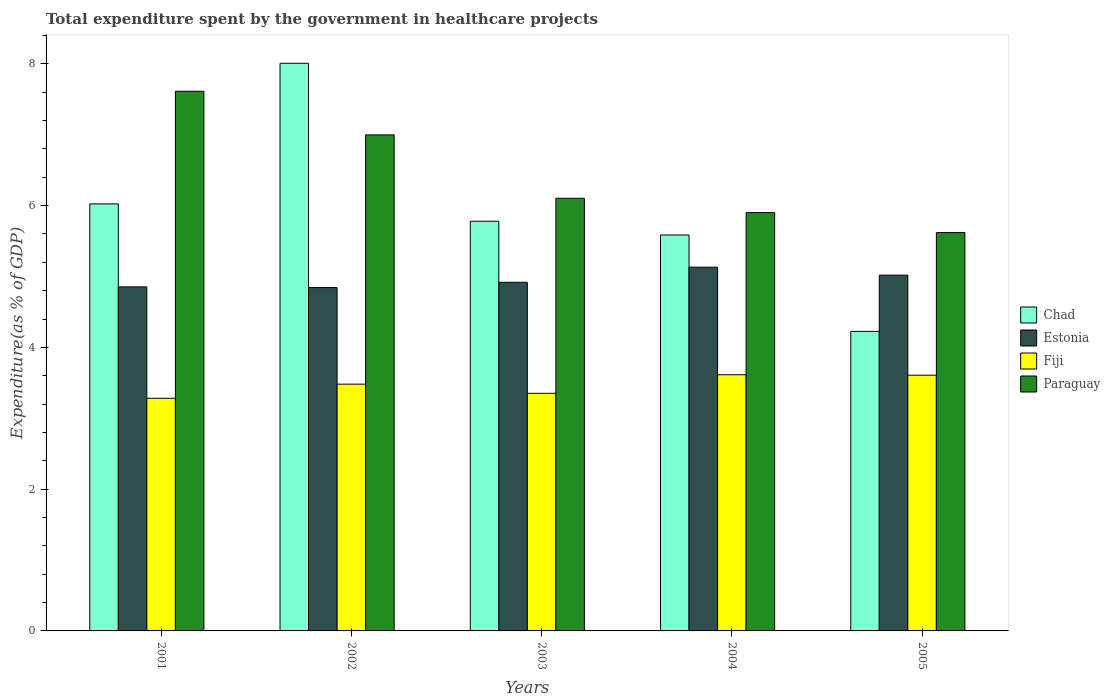How many groups of bars are there?
Keep it short and to the point. 5. Are the number of bars per tick equal to the number of legend labels?
Provide a succinct answer. Yes. What is the label of the 2nd group of bars from the left?
Offer a very short reply. 2002. In how many cases, is the number of bars for a given year not equal to the number of legend labels?
Make the answer very short. 0. What is the total expenditure spent by the government in healthcare projects in Chad in 2002?
Keep it short and to the point. 8.01. Across all years, what is the maximum total expenditure spent by the government in healthcare projects in Fiji?
Offer a terse response. 3.61. Across all years, what is the minimum total expenditure spent by the government in healthcare projects in Chad?
Your answer should be compact. 4.23. In which year was the total expenditure spent by the government in healthcare projects in Paraguay maximum?
Offer a terse response. 2001. What is the total total expenditure spent by the government in healthcare projects in Paraguay in the graph?
Make the answer very short. 32.24. What is the difference between the total expenditure spent by the government in healthcare projects in Chad in 2002 and that in 2004?
Provide a succinct answer. 2.42. What is the difference between the total expenditure spent by the government in healthcare projects in Paraguay in 2003 and the total expenditure spent by the government in healthcare projects in Estonia in 2002?
Ensure brevity in your answer.  1.26. What is the average total expenditure spent by the government in healthcare projects in Chad per year?
Your response must be concise. 5.93. In the year 2002, what is the difference between the total expenditure spent by the government in healthcare projects in Paraguay and total expenditure spent by the government in healthcare projects in Fiji?
Offer a terse response. 3.52. In how many years, is the total expenditure spent by the government in healthcare projects in Fiji greater than 0.4 %?
Your response must be concise. 5. What is the ratio of the total expenditure spent by the government in healthcare projects in Paraguay in 2001 to that in 2004?
Give a very brief answer. 1.29. What is the difference between the highest and the second highest total expenditure spent by the government in healthcare projects in Chad?
Offer a terse response. 1.98. What is the difference between the highest and the lowest total expenditure spent by the government in healthcare projects in Chad?
Provide a short and direct response. 3.78. Is it the case that in every year, the sum of the total expenditure spent by the government in healthcare projects in Estonia and total expenditure spent by the government in healthcare projects in Chad is greater than the sum of total expenditure spent by the government in healthcare projects in Fiji and total expenditure spent by the government in healthcare projects in Paraguay?
Your answer should be compact. Yes. What does the 4th bar from the left in 2004 represents?
Your response must be concise. Paraguay. What does the 4th bar from the right in 2003 represents?
Make the answer very short. Chad. Are all the bars in the graph horizontal?
Offer a very short reply. No. Does the graph contain any zero values?
Offer a terse response. No. Does the graph contain grids?
Offer a terse response. No. How many legend labels are there?
Your answer should be compact. 4. How are the legend labels stacked?
Your answer should be compact. Vertical. What is the title of the graph?
Offer a terse response. Total expenditure spent by the government in healthcare projects. Does "Madagascar" appear as one of the legend labels in the graph?
Offer a terse response. No. What is the label or title of the X-axis?
Provide a succinct answer. Years. What is the label or title of the Y-axis?
Ensure brevity in your answer.  Expenditure(as % of GDP). What is the Expenditure(as % of GDP) in Chad in 2001?
Your answer should be compact. 6.02. What is the Expenditure(as % of GDP) in Estonia in 2001?
Provide a short and direct response. 4.85. What is the Expenditure(as % of GDP) in Fiji in 2001?
Keep it short and to the point. 3.28. What is the Expenditure(as % of GDP) in Paraguay in 2001?
Offer a terse response. 7.61. What is the Expenditure(as % of GDP) of Chad in 2002?
Offer a very short reply. 8.01. What is the Expenditure(as % of GDP) in Estonia in 2002?
Offer a very short reply. 4.84. What is the Expenditure(as % of GDP) of Fiji in 2002?
Make the answer very short. 3.48. What is the Expenditure(as % of GDP) of Paraguay in 2002?
Your response must be concise. 7. What is the Expenditure(as % of GDP) of Chad in 2003?
Give a very brief answer. 5.78. What is the Expenditure(as % of GDP) of Estonia in 2003?
Offer a terse response. 4.92. What is the Expenditure(as % of GDP) of Fiji in 2003?
Offer a very short reply. 3.35. What is the Expenditure(as % of GDP) in Paraguay in 2003?
Give a very brief answer. 6.1. What is the Expenditure(as % of GDP) of Chad in 2004?
Make the answer very short. 5.59. What is the Expenditure(as % of GDP) of Estonia in 2004?
Your answer should be very brief. 5.13. What is the Expenditure(as % of GDP) of Fiji in 2004?
Offer a terse response. 3.61. What is the Expenditure(as % of GDP) of Paraguay in 2004?
Your answer should be compact. 5.9. What is the Expenditure(as % of GDP) of Chad in 2005?
Offer a very short reply. 4.23. What is the Expenditure(as % of GDP) in Estonia in 2005?
Make the answer very short. 5.02. What is the Expenditure(as % of GDP) of Fiji in 2005?
Your response must be concise. 3.61. What is the Expenditure(as % of GDP) in Paraguay in 2005?
Offer a very short reply. 5.62. Across all years, what is the maximum Expenditure(as % of GDP) in Chad?
Your answer should be compact. 8.01. Across all years, what is the maximum Expenditure(as % of GDP) of Estonia?
Your answer should be compact. 5.13. Across all years, what is the maximum Expenditure(as % of GDP) of Fiji?
Ensure brevity in your answer.  3.61. Across all years, what is the maximum Expenditure(as % of GDP) in Paraguay?
Your response must be concise. 7.61. Across all years, what is the minimum Expenditure(as % of GDP) of Chad?
Provide a succinct answer. 4.23. Across all years, what is the minimum Expenditure(as % of GDP) of Estonia?
Your response must be concise. 4.84. Across all years, what is the minimum Expenditure(as % of GDP) of Fiji?
Make the answer very short. 3.28. Across all years, what is the minimum Expenditure(as % of GDP) of Paraguay?
Your answer should be compact. 5.62. What is the total Expenditure(as % of GDP) in Chad in the graph?
Give a very brief answer. 29.63. What is the total Expenditure(as % of GDP) in Estonia in the graph?
Your answer should be compact. 24.77. What is the total Expenditure(as % of GDP) of Fiji in the graph?
Offer a terse response. 17.34. What is the total Expenditure(as % of GDP) of Paraguay in the graph?
Give a very brief answer. 32.24. What is the difference between the Expenditure(as % of GDP) in Chad in 2001 and that in 2002?
Your answer should be compact. -1.98. What is the difference between the Expenditure(as % of GDP) of Estonia in 2001 and that in 2002?
Ensure brevity in your answer.  0.01. What is the difference between the Expenditure(as % of GDP) in Fiji in 2001 and that in 2002?
Offer a terse response. -0.2. What is the difference between the Expenditure(as % of GDP) in Paraguay in 2001 and that in 2002?
Your answer should be very brief. 0.62. What is the difference between the Expenditure(as % of GDP) of Chad in 2001 and that in 2003?
Provide a short and direct response. 0.24. What is the difference between the Expenditure(as % of GDP) in Estonia in 2001 and that in 2003?
Give a very brief answer. -0.06. What is the difference between the Expenditure(as % of GDP) of Fiji in 2001 and that in 2003?
Your answer should be very brief. -0.07. What is the difference between the Expenditure(as % of GDP) of Paraguay in 2001 and that in 2003?
Your answer should be compact. 1.51. What is the difference between the Expenditure(as % of GDP) in Chad in 2001 and that in 2004?
Offer a terse response. 0.44. What is the difference between the Expenditure(as % of GDP) in Estonia in 2001 and that in 2004?
Give a very brief answer. -0.28. What is the difference between the Expenditure(as % of GDP) of Fiji in 2001 and that in 2004?
Your answer should be compact. -0.33. What is the difference between the Expenditure(as % of GDP) in Paraguay in 2001 and that in 2004?
Provide a short and direct response. 1.71. What is the difference between the Expenditure(as % of GDP) of Chad in 2001 and that in 2005?
Provide a short and direct response. 1.8. What is the difference between the Expenditure(as % of GDP) of Estonia in 2001 and that in 2005?
Your answer should be compact. -0.17. What is the difference between the Expenditure(as % of GDP) of Fiji in 2001 and that in 2005?
Your response must be concise. -0.33. What is the difference between the Expenditure(as % of GDP) of Paraguay in 2001 and that in 2005?
Your response must be concise. 1.99. What is the difference between the Expenditure(as % of GDP) of Chad in 2002 and that in 2003?
Give a very brief answer. 2.23. What is the difference between the Expenditure(as % of GDP) of Estonia in 2002 and that in 2003?
Keep it short and to the point. -0.07. What is the difference between the Expenditure(as % of GDP) in Fiji in 2002 and that in 2003?
Keep it short and to the point. 0.13. What is the difference between the Expenditure(as % of GDP) in Paraguay in 2002 and that in 2003?
Your response must be concise. 0.89. What is the difference between the Expenditure(as % of GDP) in Chad in 2002 and that in 2004?
Ensure brevity in your answer.  2.42. What is the difference between the Expenditure(as % of GDP) in Estonia in 2002 and that in 2004?
Give a very brief answer. -0.29. What is the difference between the Expenditure(as % of GDP) in Fiji in 2002 and that in 2004?
Offer a very short reply. -0.13. What is the difference between the Expenditure(as % of GDP) of Paraguay in 2002 and that in 2004?
Give a very brief answer. 1.1. What is the difference between the Expenditure(as % of GDP) in Chad in 2002 and that in 2005?
Ensure brevity in your answer.  3.78. What is the difference between the Expenditure(as % of GDP) in Estonia in 2002 and that in 2005?
Make the answer very short. -0.18. What is the difference between the Expenditure(as % of GDP) of Fiji in 2002 and that in 2005?
Your answer should be very brief. -0.13. What is the difference between the Expenditure(as % of GDP) of Paraguay in 2002 and that in 2005?
Make the answer very short. 1.38. What is the difference between the Expenditure(as % of GDP) of Chad in 2003 and that in 2004?
Provide a succinct answer. 0.19. What is the difference between the Expenditure(as % of GDP) of Estonia in 2003 and that in 2004?
Your answer should be very brief. -0.21. What is the difference between the Expenditure(as % of GDP) of Fiji in 2003 and that in 2004?
Provide a short and direct response. -0.26. What is the difference between the Expenditure(as % of GDP) in Paraguay in 2003 and that in 2004?
Your answer should be very brief. 0.2. What is the difference between the Expenditure(as % of GDP) in Chad in 2003 and that in 2005?
Offer a terse response. 1.55. What is the difference between the Expenditure(as % of GDP) of Estonia in 2003 and that in 2005?
Ensure brevity in your answer.  -0.1. What is the difference between the Expenditure(as % of GDP) in Fiji in 2003 and that in 2005?
Give a very brief answer. -0.26. What is the difference between the Expenditure(as % of GDP) of Paraguay in 2003 and that in 2005?
Keep it short and to the point. 0.48. What is the difference between the Expenditure(as % of GDP) of Chad in 2004 and that in 2005?
Make the answer very short. 1.36. What is the difference between the Expenditure(as % of GDP) of Estonia in 2004 and that in 2005?
Your response must be concise. 0.11. What is the difference between the Expenditure(as % of GDP) of Fiji in 2004 and that in 2005?
Make the answer very short. 0.01. What is the difference between the Expenditure(as % of GDP) of Paraguay in 2004 and that in 2005?
Your answer should be compact. 0.28. What is the difference between the Expenditure(as % of GDP) of Chad in 2001 and the Expenditure(as % of GDP) of Estonia in 2002?
Give a very brief answer. 1.18. What is the difference between the Expenditure(as % of GDP) of Chad in 2001 and the Expenditure(as % of GDP) of Fiji in 2002?
Offer a terse response. 2.54. What is the difference between the Expenditure(as % of GDP) in Chad in 2001 and the Expenditure(as % of GDP) in Paraguay in 2002?
Give a very brief answer. -0.97. What is the difference between the Expenditure(as % of GDP) of Estonia in 2001 and the Expenditure(as % of GDP) of Fiji in 2002?
Provide a succinct answer. 1.37. What is the difference between the Expenditure(as % of GDP) in Estonia in 2001 and the Expenditure(as % of GDP) in Paraguay in 2002?
Your response must be concise. -2.14. What is the difference between the Expenditure(as % of GDP) in Fiji in 2001 and the Expenditure(as % of GDP) in Paraguay in 2002?
Provide a succinct answer. -3.72. What is the difference between the Expenditure(as % of GDP) in Chad in 2001 and the Expenditure(as % of GDP) in Estonia in 2003?
Offer a terse response. 1.11. What is the difference between the Expenditure(as % of GDP) in Chad in 2001 and the Expenditure(as % of GDP) in Fiji in 2003?
Your answer should be compact. 2.67. What is the difference between the Expenditure(as % of GDP) of Chad in 2001 and the Expenditure(as % of GDP) of Paraguay in 2003?
Make the answer very short. -0.08. What is the difference between the Expenditure(as % of GDP) of Estonia in 2001 and the Expenditure(as % of GDP) of Fiji in 2003?
Give a very brief answer. 1.5. What is the difference between the Expenditure(as % of GDP) of Estonia in 2001 and the Expenditure(as % of GDP) of Paraguay in 2003?
Provide a short and direct response. -1.25. What is the difference between the Expenditure(as % of GDP) of Fiji in 2001 and the Expenditure(as % of GDP) of Paraguay in 2003?
Offer a terse response. -2.82. What is the difference between the Expenditure(as % of GDP) in Chad in 2001 and the Expenditure(as % of GDP) in Estonia in 2004?
Ensure brevity in your answer.  0.89. What is the difference between the Expenditure(as % of GDP) in Chad in 2001 and the Expenditure(as % of GDP) in Fiji in 2004?
Your answer should be compact. 2.41. What is the difference between the Expenditure(as % of GDP) in Chad in 2001 and the Expenditure(as % of GDP) in Paraguay in 2004?
Your answer should be compact. 0.12. What is the difference between the Expenditure(as % of GDP) of Estonia in 2001 and the Expenditure(as % of GDP) of Fiji in 2004?
Ensure brevity in your answer.  1.24. What is the difference between the Expenditure(as % of GDP) in Estonia in 2001 and the Expenditure(as % of GDP) in Paraguay in 2004?
Offer a very short reply. -1.05. What is the difference between the Expenditure(as % of GDP) in Fiji in 2001 and the Expenditure(as % of GDP) in Paraguay in 2004?
Your response must be concise. -2.62. What is the difference between the Expenditure(as % of GDP) in Chad in 2001 and the Expenditure(as % of GDP) in Estonia in 2005?
Offer a terse response. 1. What is the difference between the Expenditure(as % of GDP) of Chad in 2001 and the Expenditure(as % of GDP) of Fiji in 2005?
Provide a succinct answer. 2.42. What is the difference between the Expenditure(as % of GDP) of Chad in 2001 and the Expenditure(as % of GDP) of Paraguay in 2005?
Offer a very short reply. 0.4. What is the difference between the Expenditure(as % of GDP) in Estonia in 2001 and the Expenditure(as % of GDP) in Fiji in 2005?
Your response must be concise. 1.25. What is the difference between the Expenditure(as % of GDP) of Estonia in 2001 and the Expenditure(as % of GDP) of Paraguay in 2005?
Provide a short and direct response. -0.77. What is the difference between the Expenditure(as % of GDP) of Fiji in 2001 and the Expenditure(as % of GDP) of Paraguay in 2005?
Provide a short and direct response. -2.34. What is the difference between the Expenditure(as % of GDP) of Chad in 2002 and the Expenditure(as % of GDP) of Estonia in 2003?
Your answer should be compact. 3.09. What is the difference between the Expenditure(as % of GDP) of Chad in 2002 and the Expenditure(as % of GDP) of Fiji in 2003?
Provide a short and direct response. 4.66. What is the difference between the Expenditure(as % of GDP) in Chad in 2002 and the Expenditure(as % of GDP) in Paraguay in 2003?
Your answer should be very brief. 1.9. What is the difference between the Expenditure(as % of GDP) in Estonia in 2002 and the Expenditure(as % of GDP) in Fiji in 2003?
Provide a short and direct response. 1.49. What is the difference between the Expenditure(as % of GDP) in Estonia in 2002 and the Expenditure(as % of GDP) in Paraguay in 2003?
Give a very brief answer. -1.26. What is the difference between the Expenditure(as % of GDP) of Fiji in 2002 and the Expenditure(as % of GDP) of Paraguay in 2003?
Offer a terse response. -2.62. What is the difference between the Expenditure(as % of GDP) in Chad in 2002 and the Expenditure(as % of GDP) in Estonia in 2004?
Your response must be concise. 2.88. What is the difference between the Expenditure(as % of GDP) of Chad in 2002 and the Expenditure(as % of GDP) of Fiji in 2004?
Make the answer very short. 4.39. What is the difference between the Expenditure(as % of GDP) in Chad in 2002 and the Expenditure(as % of GDP) in Paraguay in 2004?
Provide a short and direct response. 2.11. What is the difference between the Expenditure(as % of GDP) of Estonia in 2002 and the Expenditure(as % of GDP) of Fiji in 2004?
Keep it short and to the point. 1.23. What is the difference between the Expenditure(as % of GDP) in Estonia in 2002 and the Expenditure(as % of GDP) in Paraguay in 2004?
Your answer should be compact. -1.06. What is the difference between the Expenditure(as % of GDP) of Fiji in 2002 and the Expenditure(as % of GDP) of Paraguay in 2004?
Your response must be concise. -2.42. What is the difference between the Expenditure(as % of GDP) in Chad in 2002 and the Expenditure(as % of GDP) in Estonia in 2005?
Make the answer very short. 2.99. What is the difference between the Expenditure(as % of GDP) of Chad in 2002 and the Expenditure(as % of GDP) of Fiji in 2005?
Ensure brevity in your answer.  4.4. What is the difference between the Expenditure(as % of GDP) in Chad in 2002 and the Expenditure(as % of GDP) in Paraguay in 2005?
Your answer should be compact. 2.39. What is the difference between the Expenditure(as % of GDP) in Estonia in 2002 and the Expenditure(as % of GDP) in Fiji in 2005?
Make the answer very short. 1.24. What is the difference between the Expenditure(as % of GDP) of Estonia in 2002 and the Expenditure(as % of GDP) of Paraguay in 2005?
Ensure brevity in your answer.  -0.78. What is the difference between the Expenditure(as % of GDP) of Fiji in 2002 and the Expenditure(as % of GDP) of Paraguay in 2005?
Your response must be concise. -2.14. What is the difference between the Expenditure(as % of GDP) in Chad in 2003 and the Expenditure(as % of GDP) in Estonia in 2004?
Offer a very short reply. 0.65. What is the difference between the Expenditure(as % of GDP) of Chad in 2003 and the Expenditure(as % of GDP) of Fiji in 2004?
Give a very brief answer. 2.17. What is the difference between the Expenditure(as % of GDP) of Chad in 2003 and the Expenditure(as % of GDP) of Paraguay in 2004?
Give a very brief answer. -0.12. What is the difference between the Expenditure(as % of GDP) in Estonia in 2003 and the Expenditure(as % of GDP) in Fiji in 2004?
Provide a succinct answer. 1.3. What is the difference between the Expenditure(as % of GDP) in Estonia in 2003 and the Expenditure(as % of GDP) in Paraguay in 2004?
Ensure brevity in your answer.  -0.98. What is the difference between the Expenditure(as % of GDP) in Fiji in 2003 and the Expenditure(as % of GDP) in Paraguay in 2004?
Make the answer very short. -2.55. What is the difference between the Expenditure(as % of GDP) of Chad in 2003 and the Expenditure(as % of GDP) of Estonia in 2005?
Your response must be concise. 0.76. What is the difference between the Expenditure(as % of GDP) of Chad in 2003 and the Expenditure(as % of GDP) of Fiji in 2005?
Make the answer very short. 2.17. What is the difference between the Expenditure(as % of GDP) in Chad in 2003 and the Expenditure(as % of GDP) in Paraguay in 2005?
Offer a very short reply. 0.16. What is the difference between the Expenditure(as % of GDP) in Estonia in 2003 and the Expenditure(as % of GDP) in Fiji in 2005?
Ensure brevity in your answer.  1.31. What is the difference between the Expenditure(as % of GDP) of Estonia in 2003 and the Expenditure(as % of GDP) of Paraguay in 2005?
Provide a succinct answer. -0.7. What is the difference between the Expenditure(as % of GDP) in Fiji in 2003 and the Expenditure(as % of GDP) in Paraguay in 2005?
Ensure brevity in your answer.  -2.27. What is the difference between the Expenditure(as % of GDP) in Chad in 2004 and the Expenditure(as % of GDP) in Estonia in 2005?
Your answer should be very brief. 0.57. What is the difference between the Expenditure(as % of GDP) of Chad in 2004 and the Expenditure(as % of GDP) of Fiji in 2005?
Your response must be concise. 1.98. What is the difference between the Expenditure(as % of GDP) of Chad in 2004 and the Expenditure(as % of GDP) of Paraguay in 2005?
Your answer should be compact. -0.03. What is the difference between the Expenditure(as % of GDP) in Estonia in 2004 and the Expenditure(as % of GDP) in Fiji in 2005?
Your answer should be compact. 1.52. What is the difference between the Expenditure(as % of GDP) in Estonia in 2004 and the Expenditure(as % of GDP) in Paraguay in 2005?
Keep it short and to the point. -0.49. What is the difference between the Expenditure(as % of GDP) of Fiji in 2004 and the Expenditure(as % of GDP) of Paraguay in 2005?
Give a very brief answer. -2.01. What is the average Expenditure(as % of GDP) of Chad per year?
Your response must be concise. 5.93. What is the average Expenditure(as % of GDP) of Estonia per year?
Your answer should be compact. 4.95. What is the average Expenditure(as % of GDP) in Fiji per year?
Ensure brevity in your answer.  3.47. What is the average Expenditure(as % of GDP) of Paraguay per year?
Your response must be concise. 6.45. In the year 2001, what is the difference between the Expenditure(as % of GDP) of Chad and Expenditure(as % of GDP) of Estonia?
Provide a succinct answer. 1.17. In the year 2001, what is the difference between the Expenditure(as % of GDP) in Chad and Expenditure(as % of GDP) in Fiji?
Keep it short and to the point. 2.74. In the year 2001, what is the difference between the Expenditure(as % of GDP) in Chad and Expenditure(as % of GDP) in Paraguay?
Keep it short and to the point. -1.59. In the year 2001, what is the difference between the Expenditure(as % of GDP) in Estonia and Expenditure(as % of GDP) in Fiji?
Ensure brevity in your answer.  1.57. In the year 2001, what is the difference between the Expenditure(as % of GDP) of Estonia and Expenditure(as % of GDP) of Paraguay?
Your answer should be compact. -2.76. In the year 2001, what is the difference between the Expenditure(as % of GDP) of Fiji and Expenditure(as % of GDP) of Paraguay?
Make the answer very short. -4.33. In the year 2002, what is the difference between the Expenditure(as % of GDP) of Chad and Expenditure(as % of GDP) of Estonia?
Give a very brief answer. 3.16. In the year 2002, what is the difference between the Expenditure(as % of GDP) of Chad and Expenditure(as % of GDP) of Fiji?
Keep it short and to the point. 4.53. In the year 2002, what is the difference between the Expenditure(as % of GDP) of Chad and Expenditure(as % of GDP) of Paraguay?
Ensure brevity in your answer.  1.01. In the year 2002, what is the difference between the Expenditure(as % of GDP) in Estonia and Expenditure(as % of GDP) in Fiji?
Offer a terse response. 1.36. In the year 2002, what is the difference between the Expenditure(as % of GDP) in Estonia and Expenditure(as % of GDP) in Paraguay?
Provide a short and direct response. -2.15. In the year 2002, what is the difference between the Expenditure(as % of GDP) of Fiji and Expenditure(as % of GDP) of Paraguay?
Offer a terse response. -3.52. In the year 2003, what is the difference between the Expenditure(as % of GDP) in Chad and Expenditure(as % of GDP) in Estonia?
Offer a very short reply. 0.86. In the year 2003, what is the difference between the Expenditure(as % of GDP) in Chad and Expenditure(as % of GDP) in Fiji?
Ensure brevity in your answer.  2.43. In the year 2003, what is the difference between the Expenditure(as % of GDP) of Chad and Expenditure(as % of GDP) of Paraguay?
Make the answer very short. -0.32. In the year 2003, what is the difference between the Expenditure(as % of GDP) of Estonia and Expenditure(as % of GDP) of Fiji?
Provide a short and direct response. 1.57. In the year 2003, what is the difference between the Expenditure(as % of GDP) of Estonia and Expenditure(as % of GDP) of Paraguay?
Give a very brief answer. -1.19. In the year 2003, what is the difference between the Expenditure(as % of GDP) in Fiji and Expenditure(as % of GDP) in Paraguay?
Your answer should be very brief. -2.75. In the year 2004, what is the difference between the Expenditure(as % of GDP) of Chad and Expenditure(as % of GDP) of Estonia?
Keep it short and to the point. 0.45. In the year 2004, what is the difference between the Expenditure(as % of GDP) of Chad and Expenditure(as % of GDP) of Fiji?
Ensure brevity in your answer.  1.97. In the year 2004, what is the difference between the Expenditure(as % of GDP) of Chad and Expenditure(as % of GDP) of Paraguay?
Provide a succinct answer. -0.32. In the year 2004, what is the difference between the Expenditure(as % of GDP) in Estonia and Expenditure(as % of GDP) in Fiji?
Keep it short and to the point. 1.52. In the year 2004, what is the difference between the Expenditure(as % of GDP) in Estonia and Expenditure(as % of GDP) in Paraguay?
Make the answer very short. -0.77. In the year 2004, what is the difference between the Expenditure(as % of GDP) of Fiji and Expenditure(as % of GDP) of Paraguay?
Your answer should be compact. -2.29. In the year 2005, what is the difference between the Expenditure(as % of GDP) in Chad and Expenditure(as % of GDP) in Estonia?
Ensure brevity in your answer.  -0.79. In the year 2005, what is the difference between the Expenditure(as % of GDP) of Chad and Expenditure(as % of GDP) of Fiji?
Your response must be concise. 0.62. In the year 2005, what is the difference between the Expenditure(as % of GDP) in Chad and Expenditure(as % of GDP) in Paraguay?
Your answer should be very brief. -1.39. In the year 2005, what is the difference between the Expenditure(as % of GDP) of Estonia and Expenditure(as % of GDP) of Fiji?
Your answer should be very brief. 1.41. In the year 2005, what is the difference between the Expenditure(as % of GDP) of Estonia and Expenditure(as % of GDP) of Paraguay?
Your answer should be very brief. -0.6. In the year 2005, what is the difference between the Expenditure(as % of GDP) in Fiji and Expenditure(as % of GDP) in Paraguay?
Offer a very short reply. -2.01. What is the ratio of the Expenditure(as % of GDP) of Chad in 2001 to that in 2002?
Make the answer very short. 0.75. What is the ratio of the Expenditure(as % of GDP) in Estonia in 2001 to that in 2002?
Give a very brief answer. 1. What is the ratio of the Expenditure(as % of GDP) in Fiji in 2001 to that in 2002?
Keep it short and to the point. 0.94. What is the ratio of the Expenditure(as % of GDP) in Paraguay in 2001 to that in 2002?
Provide a short and direct response. 1.09. What is the ratio of the Expenditure(as % of GDP) in Chad in 2001 to that in 2003?
Provide a short and direct response. 1.04. What is the ratio of the Expenditure(as % of GDP) in Estonia in 2001 to that in 2003?
Ensure brevity in your answer.  0.99. What is the ratio of the Expenditure(as % of GDP) in Fiji in 2001 to that in 2003?
Offer a terse response. 0.98. What is the ratio of the Expenditure(as % of GDP) in Paraguay in 2001 to that in 2003?
Ensure brevity in your answer.  1.25. What is the ratio of the Expenditure(as % of GDP) of Chad in 2001 to that in 2004?
Offer a very short reply. 1.08. What is the ratio of the Expenditure(as % of GDP) of Estonia in 2001 to that in 2004?
Provide a succinct answer. 0.95. What is the ratio of the Expenditure(as % of GDP) of Fiji in 2001 to that in 2004?
Keep it short and to the point. 0.91. What is the ratio of the Expenditure(as % of GDP) in Paraguay in 2001 to that in 2004?
Your response must be concise. 1.29. What is the ratio of the Expenditure(as % of GDP) of Chad in 2001 to that in 2005?
Your answer should be very brief. 1.43. What is the ratio of the Expenditure(as % of GDP) in Estonia in 2001 to that in 2005?
Offer a terse response. 0.97. What is the ratio of the Expenditure(as % of GDP) in Fiji in 2001 to that in 2005?
Your response must be concise. 0.91. What is the ratio of the Expenditure(as % of GDP) of Paraguay in 2001 to that in 2005?
Provide a succinct answer. 1.35. What is the ratio of the Expenditure(as % of GDP) in Chad in 2002 to that in 2003?
Provide a succinct answer. 1.39. What is the ratio of the Expenditure(as % of GDP) of Fiji in 2002 to that in 2003?
Ensure brevity in your answer.  1.04. What is the ratio of the Expenditure(as % of GDP) of Paraguay in 2002 to that in 2003?
Ensure brevity in your answer.  1.15. What is the ratio of the Expenditure(as % of GDP) in Chad in 2002 to that in 2004?
Give a very brief answer. 1.43. What is the ratio of the Expenditure(as % of GDP) in Estonia in 2002 to that in 2004?
Give a very brief answer. 0.94. What is the ratio of the Expenditure(as % of GDP) in Fiji in 2002 to that in 2004?
Offer a terse response. 0.96. What is the ratio of the Expenditure(as % of GDP) of Paraguay in 2002 to that in 2004?
Your response must be concise. 1.19. What is the ratio of the Expenditure(as % of GDP) in Chad in 2002 to that in 2005?
Offer a terse response. 1.9. What is the ratio of the Expenditure(as % of GDP) of Estonia in 2002 to that in 2005?
Ensure brevity in your answer.  0.97. What is the ratio of the Expenditure(as % of GDP) in Fiji in 2002 to that in 2005?
Provide a succinct answer. 0.96. What is the ratio of the Expenditure(as % of GDP) of Paraguay in 2002 to that in 2005?
Make the answer very short. 1.25. What is the ratio of the Expenditure(as % of GDP) of Chad in 2003 to that in 2004?
Your response must be concise. 1.03. What is the ratio of the Expenditure(as % of GDP) in Estonia in 2003 to that in 2004?
Your answer should be compact. 0.96. What is the ratio of the Expenditure(as % of GDP) in Fiji in 2003 to that in 2004?
Offer a terse response. 0.93. What is the ratio of the Expenditure(as % of GDP) in Paraguay in 2003 to that in 2004?
Your response must be concise. 1.03. What is the ratio of the Expenditure(as % of GDP) in Chad in 2003 to that in 2005?
Provide a succinct answer. 1.37. What is the ratio of the Expenditure(as % of GDP) of Estonia in 2003 to that in 2005?
Ensure brevity in your answer.  0.98. What is the ratio of the Expenditure(as % of GDP) in Fiji in 2003 to that in 2005?
Provide a succinct answer. 0.93. What is the ratio of the Expenditure(as % of GDP) of Paraguay in 2003 to that in 2005?
Give a very brief answer. 1.09. What is the ratio of the Expenditure(as % of GDP) of Chad in 2004 to that in 2005?
Offer a very short reply. 1.32. What is the ratio of the Expenditure(as % of GDP) in Estonia in 2004 to that in 2005?
Give a very brief answer. 1.02. What is the ratio of the Expenditure(as % of GDP) in Paraguay in 2004 to that in 2005?
Offer a terse response. 1.05. What is the difference between the highest and the second highest Expenditure(as % of GDP) of Chad?
Give a very brief answer. 1.98. What is the difference between the highest and the second highest Expenditure(as % of GDP) in Estonia?
Make the answer very short. 0.11. What is the difference between the highest and the second highest Expenditure(as % of GDP) in Fiji?
Provide a short and direct response. 0.01. What is the difference between the highest and the second highest Expenditure(as % of GDP) in Paraguay?
Offer a terse response. 0.62. What is the difference between the highest and the lowest Expenditure(as % of GDP) of Chad?
Make the answer very short. 3.78. What is the difference between the highest and the lowest Expenditure(as % of GDP) in Estonia?
Your answer should be compact. 0.29. What is the difference between the highest and the lowest Expenditure(as % of GDP) of Fiji?
Give a very brief answer. 0.33. What is the difference between the highest and the lowest Expenditure(as % of GDP) of Paraguay?
Provide a succinct answer. 1.99. 